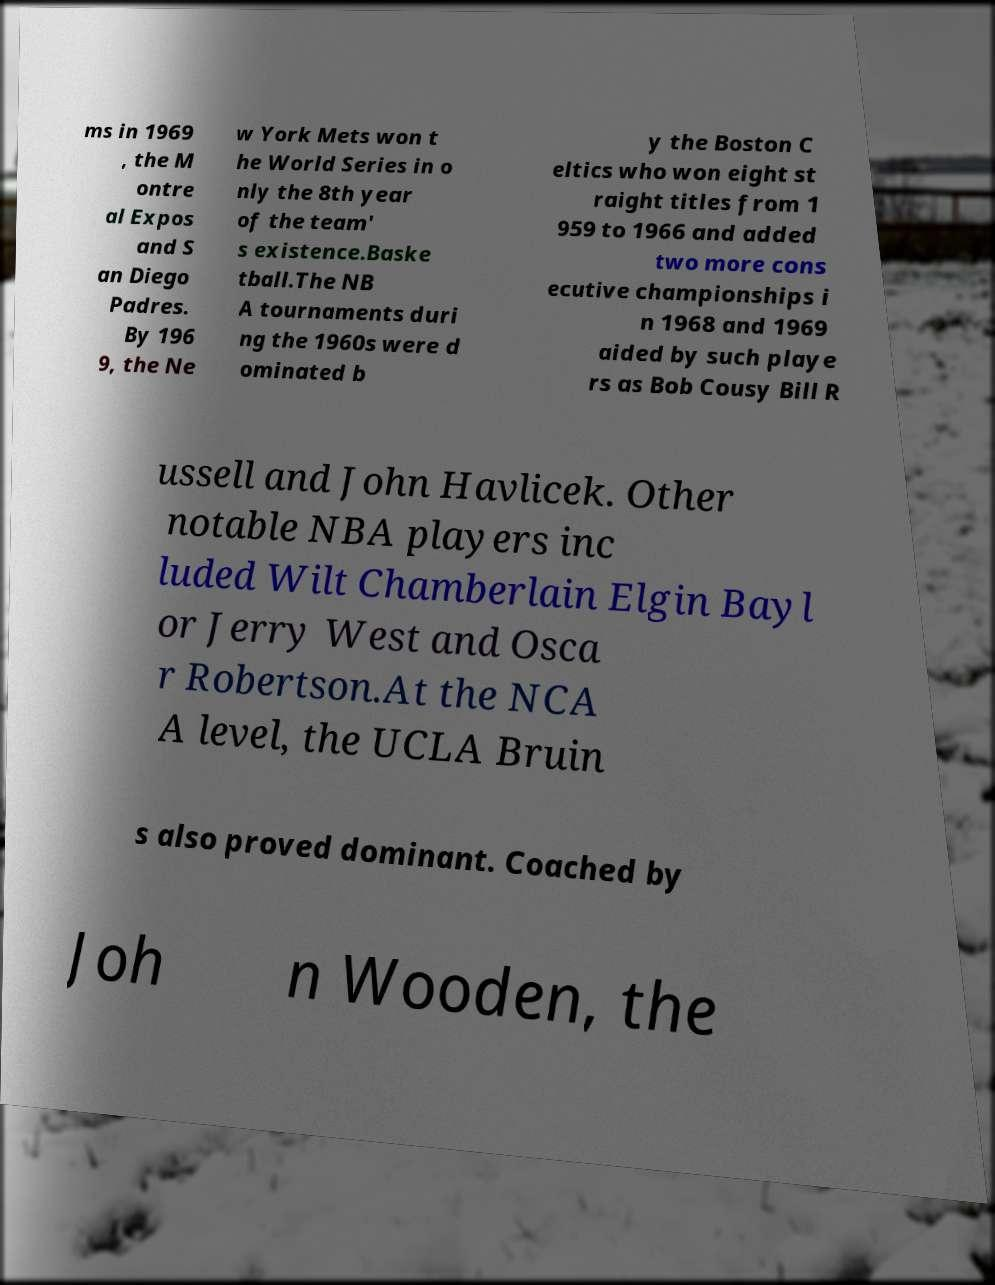I need the written content from this picture converted into text. Can you do that? ms in 1969 , the M ontre al Expos and S an Diego Padres. By 196 9, the Ne w York Mets won t he World Series in o nly the 8th year of the team' s existence.Baske tball.The NB A tournaments duri ng the 1960s were d ominated b y the Boston C eltics who won eight st raight titles from 1 959 to 1966 and added two more cons ecutive championships i n 1968 and 1969 aided by such playe rs as Bob Cousy Bill R ussell and John Havlicek. Other notable NBA players inc luded Wilt Chamberlain Elgin Bayl or Jerry West and Osca r Robertson.At the NCA A level, the UCLA Bruin s also proved dominant. Coached by Joh n Wooden, the 